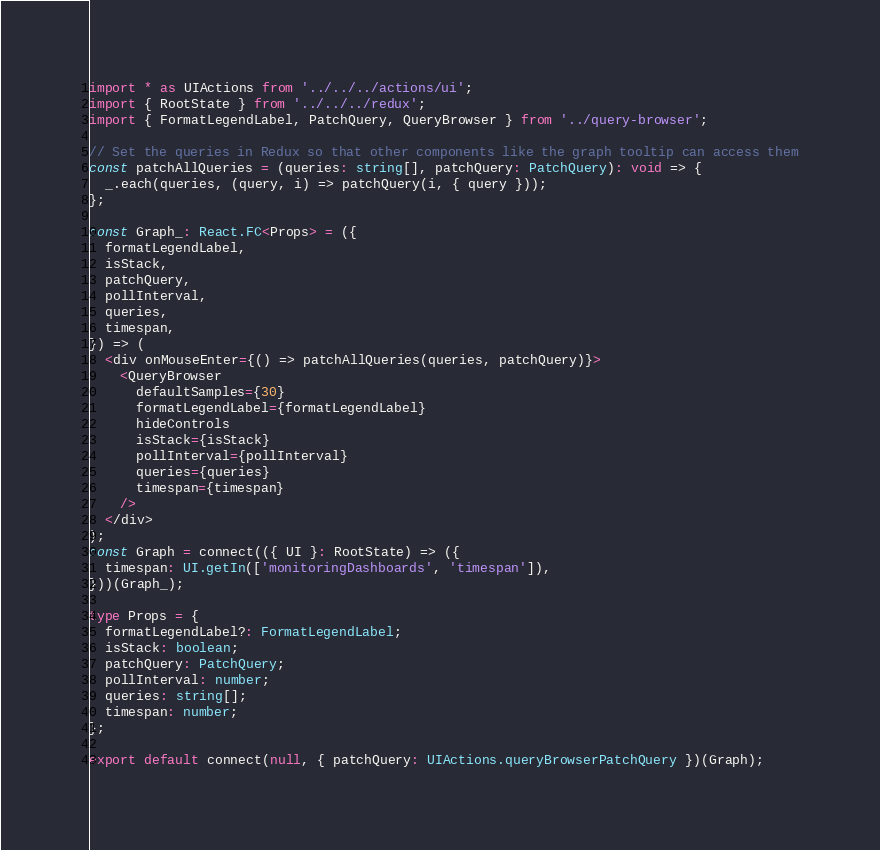<code> <loc_0><loc_0><loc_500><loc_500><_TypeScript_>
import * as UIActions from '../../../actions/ui';
import { RootState } from '../../../redux';
import { FormatLegendLabel, PatchQuery, QueryBrowser } from '../query-browser';

// Set the queries in Redux so that other components like the graph tooltip can access them
const patchAllQueries = (queries: string[], patchQuery: PatchQuery): void => {
  _.each(queries, (query, i) => patchQuery(i, { query }));
};

const Graph_: React.FC<Props> = ({
  formatLegendLabel,
  isStack,
  patchQuery,
  pollInterval,
  queries,
  timespan,
}) => (
  <div onMouseEnter={() => patchAllQueries(queries, patchQuery)}>
    <QueryBrowser
      defaultSamples={30}
      formatLegendLabel={formatLegendLabel}
      hideControls
      isStack={isStack}
      pollInterval={pollInterval}
      queries={queries}
      timespan={timespan}
    />
  </div>
);
const Graph = connect(({ UI }: RootState) => ({
  timespan: UI.getIn(['monitoringDashboards', 'timespan']),
}))(Graph_);

type Props = {
  formatLegendLabel?: FormatLegendLabel;
  isStack: boolean;
  patchQuery: PatchQuery;
  pollInterval: number;
  queries: string[];
  timespan: number;
};

export default connect(null, { patchQuery: UIActions.queryBrowserPatchQuery })(Graph);
</code> 